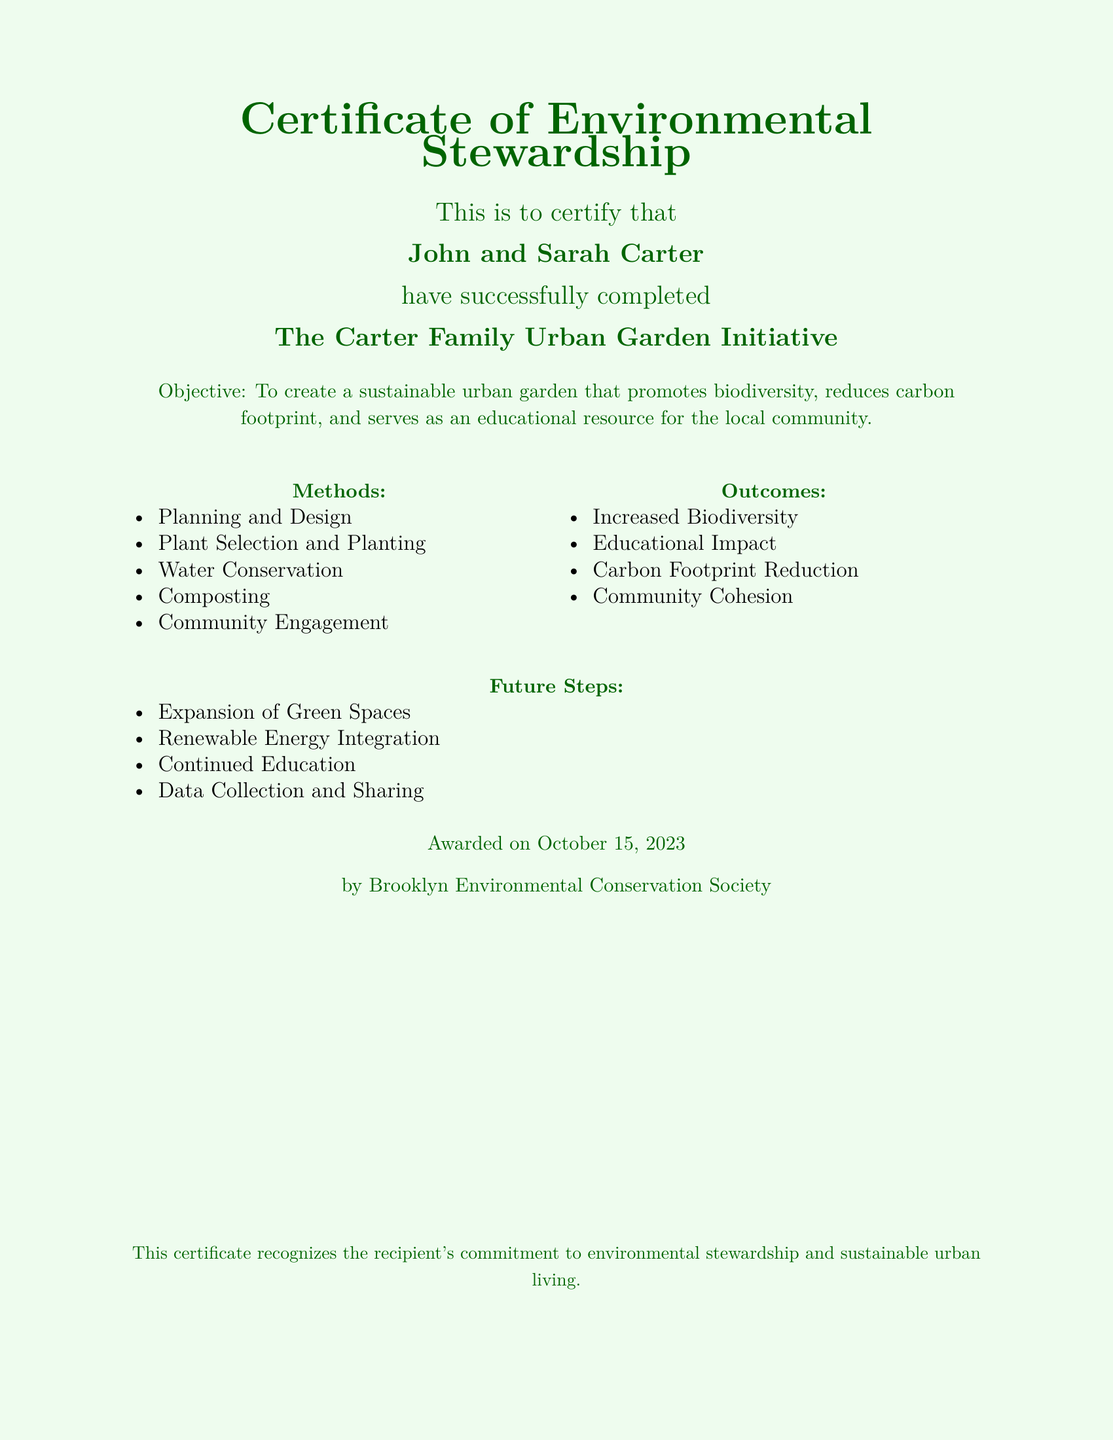What is the name of the certificate? The certificate is specifically titled "Certificate of Environmental Stewardship."
Answer: Certificate of Environmental Stewardship Who are the recipients of the certificate? The document states that John and Sarah Carter are the recipients.
Answer: John and Sarah Carter What is the name of the project? The project completed by the recipients is referred to as "The Carter Family Urban Garden Initiative."
Answer: The Carter Family Urban Garden Initiative What is the objective of the project? The objective mentioned in the document is to create a sustainable urban garden that promotes biodiversity, reduces carbon footprint, and serves as an educational resource for the local community.
Answer: To create a sustainable urban garden What date was the certificate awarded? The certificate was awarded on October 15, 2023.
Answer: October 15, 2023 What are the two key methods used in the project? The methods included in the project are Planning and Design, and Composting.
Answer: Planning and Design, Composting How many outcomes are listed in the document? The outcomes highlighted in the document total four distinct themes.
Answer: Four What future step involves energy? The future step that pertains to energy relates to the Integration of Renewable Energy.
Answer: Renewable Energy Integration What organization awarded the certificate? The awarding organization as stated in the document is the Brooklyn Environmental Conservation Society.
Answer: Brooklyn Environmental Conservation Society 